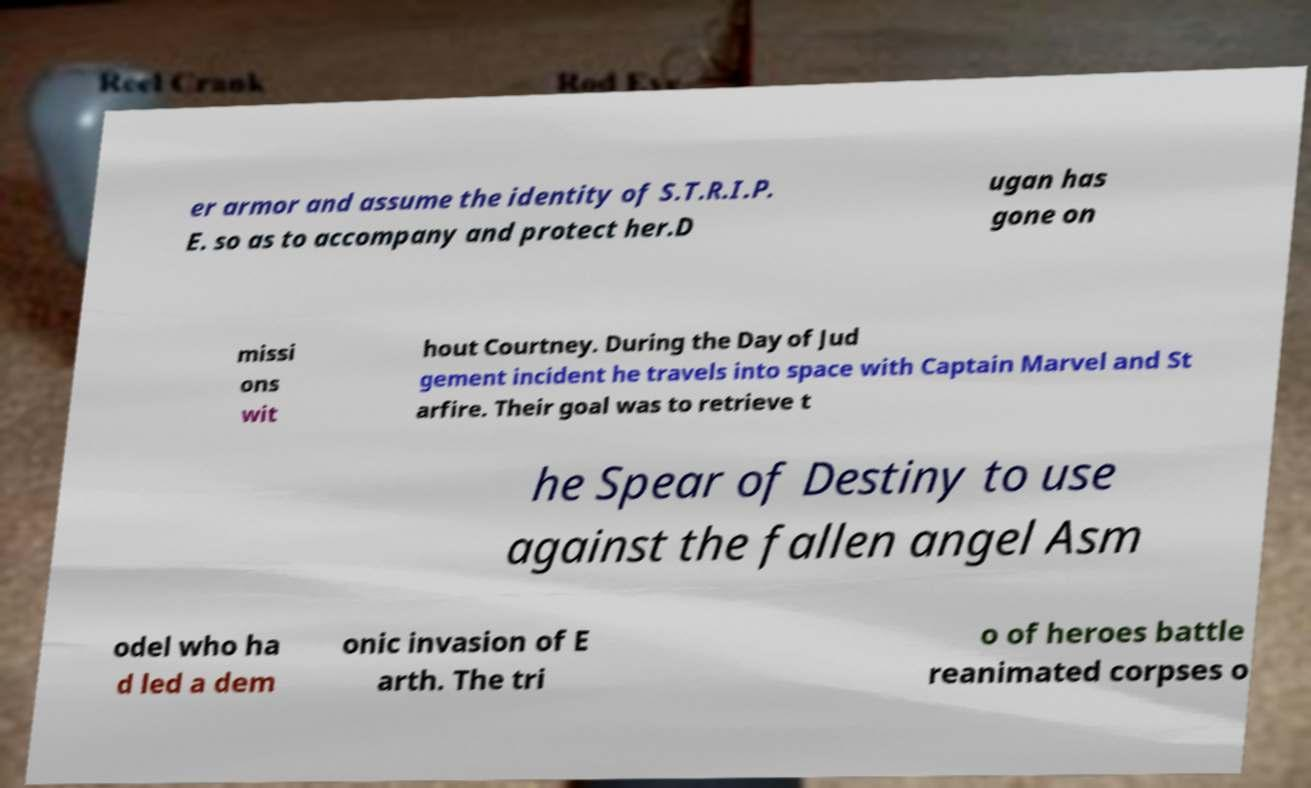Could you extract and type out the text from this image? er armor and assume the identity of S.T.R.I.P. E. so as to accompany and protect her.D ugan has gone on missi ons wit hout Courtney. During the Day of Jud gement incident he travels into space with Captain Marvel and St arfire. Their goal was to retrieve t he Spear of Destiny to use against the fallen angel Asm odel who ha d led a dem onic invasion of E arth. The tri o of heroes battle reanimated corpses o 